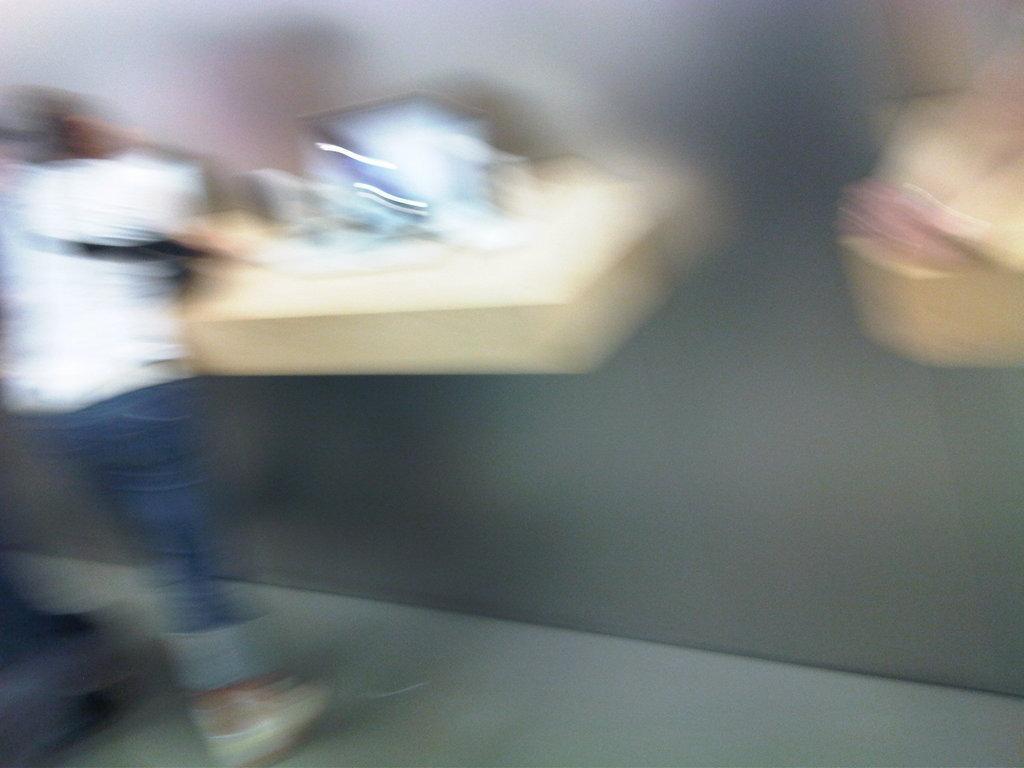Could you give a brief overview of what you see in this image? This image is blurred. On the left side there is a person. And on the wall there are some objects. 